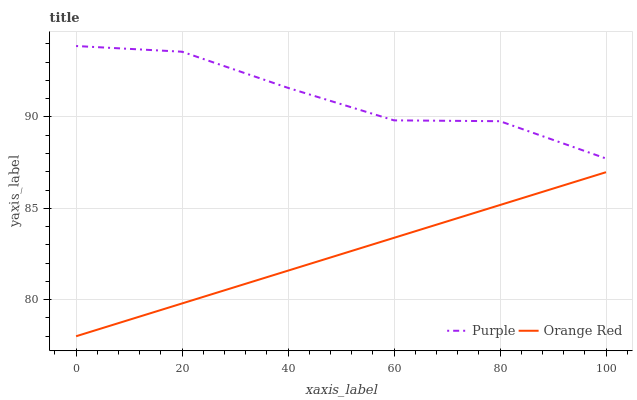Does Orange Red have the minimum area under the curve?
Answer yes or no. Yes. Does Purple have the maximum area under the curve?
Answer yes or no. Yes. Does Orange Red have the maximum area under the curve?
Answer yes or no. No. Is Orange Red the smoothest?
Answer yes or no. Yes. Is Purple the roughest?
Answer yes or no. Yes. Is Orange Red the roughest?
Answer yes or no. No. Does Orange Red have the lowest value?
Answer yes or no. Yes. Does Purple have the highest value?
Answer yes or no. Yes. Does Orange Red have the highest value?
Answer yes or no. No. Is Orange Red less than Purple?
Answer yes or no. Yes. Is Purple greater than Orange Red?
Answer yes or no. Yes. Does Orange Red intersect Purple?
Answer yes or no. No. 